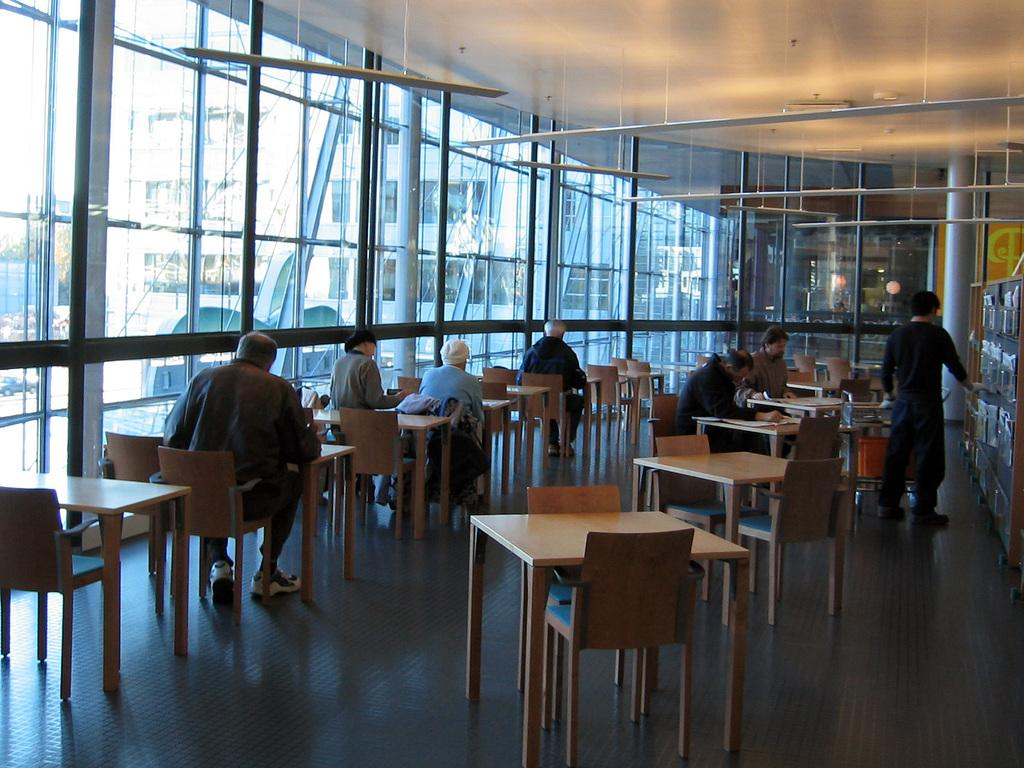How many people are in the image? There is a group of people in the image. What are some of the people doing in the image? Some people are sitting on chairs, while one person is standing. What type of furniture is present in the image? There are tables in the image. What is a unique feature of the room in the image? There is a bed in the image. What objects can be seen on the tables in the image? There are glasses on the tables in the image. What architectural elements are present in the image? There are pillars in the image. What type of storage is present in the image? There are racks in the image. What does the mother say to make the person laugh in the image? A: There is no mother or person laughing present in the image. 